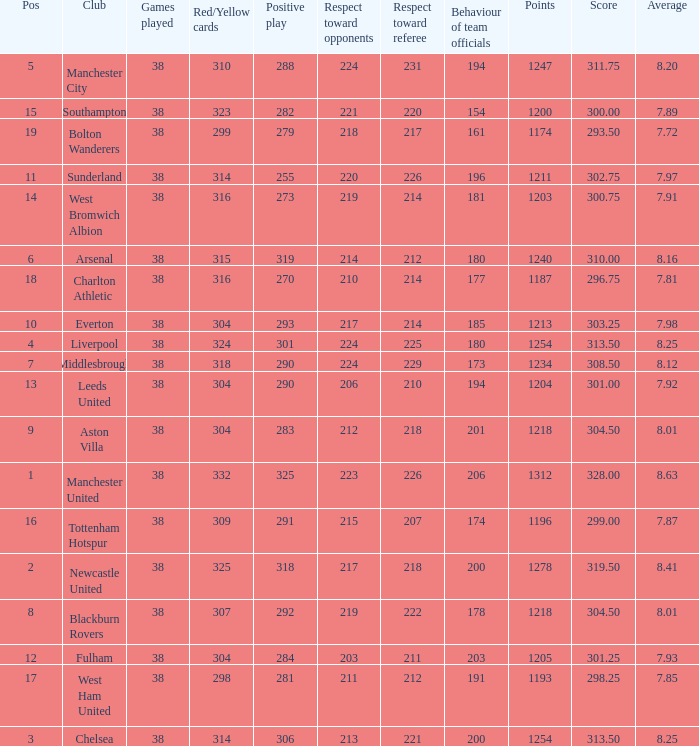Name the most pos for west bromwich albion club 14.0. 